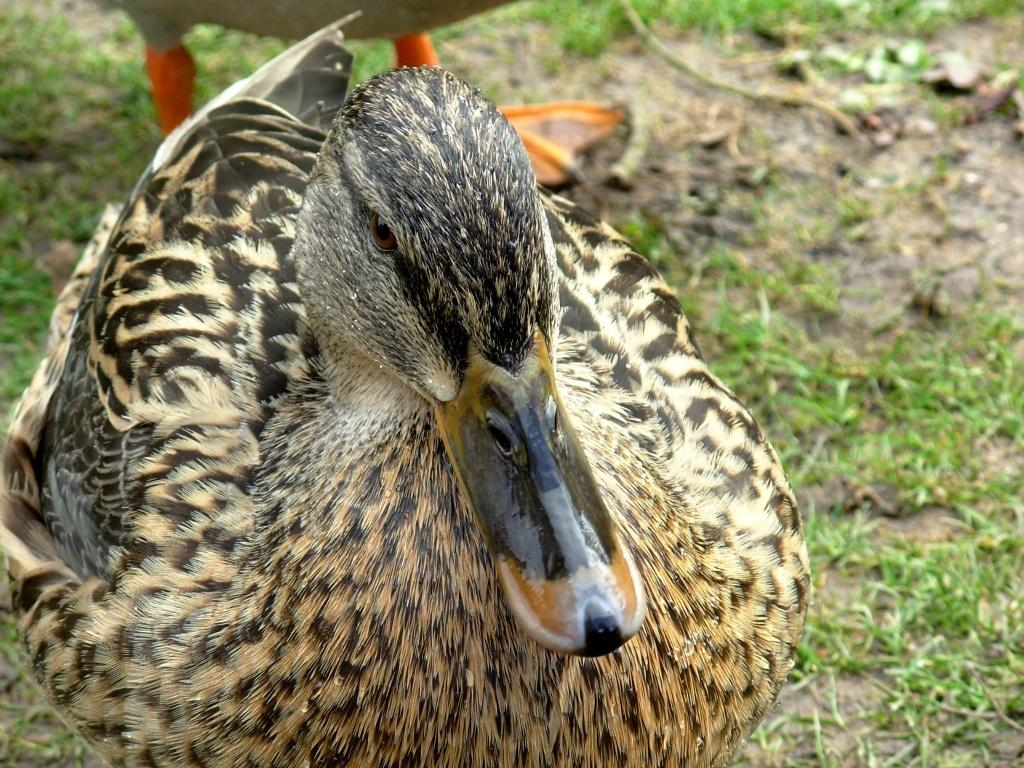What type of ground is visible in the image? There is grass ground in the image. What animals can be seen on the grass ground? There are two ducks on the grass ground. How many chairs are visible in the image? There are no chairs present in the image. What idea do the ducks have about the grass ground? The image does not provide any information about the ducks' ideas or thoughts, so it cannot be determined from the image. 